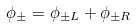Convert formula to latex. <formula><loc_0><loc_0><loc_500><loc_500>\phi _ { \pm } = \phi _ { \pm L } + \phi _ { \pm R }</formula> 